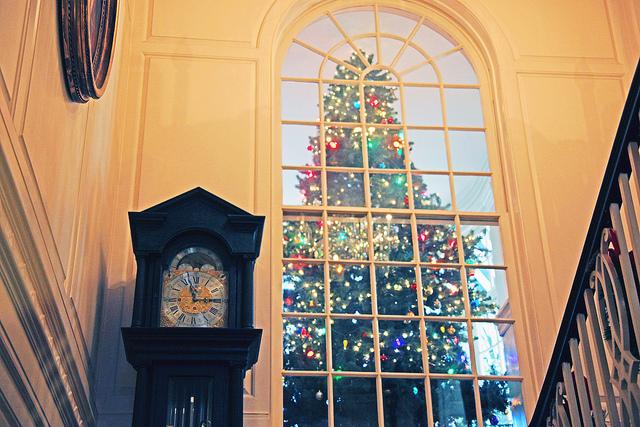What are the window's made of?
Give a very brief answer. Glass. What holiday is being represented here?
Give a very brief answer. Christmas. Is this room symmetrical?
Write a very short answer. Yes. What time does the clock say?
Concise answer only. 11:15. Is the tree the same height as the window?
Write a very short answer. Yes. 